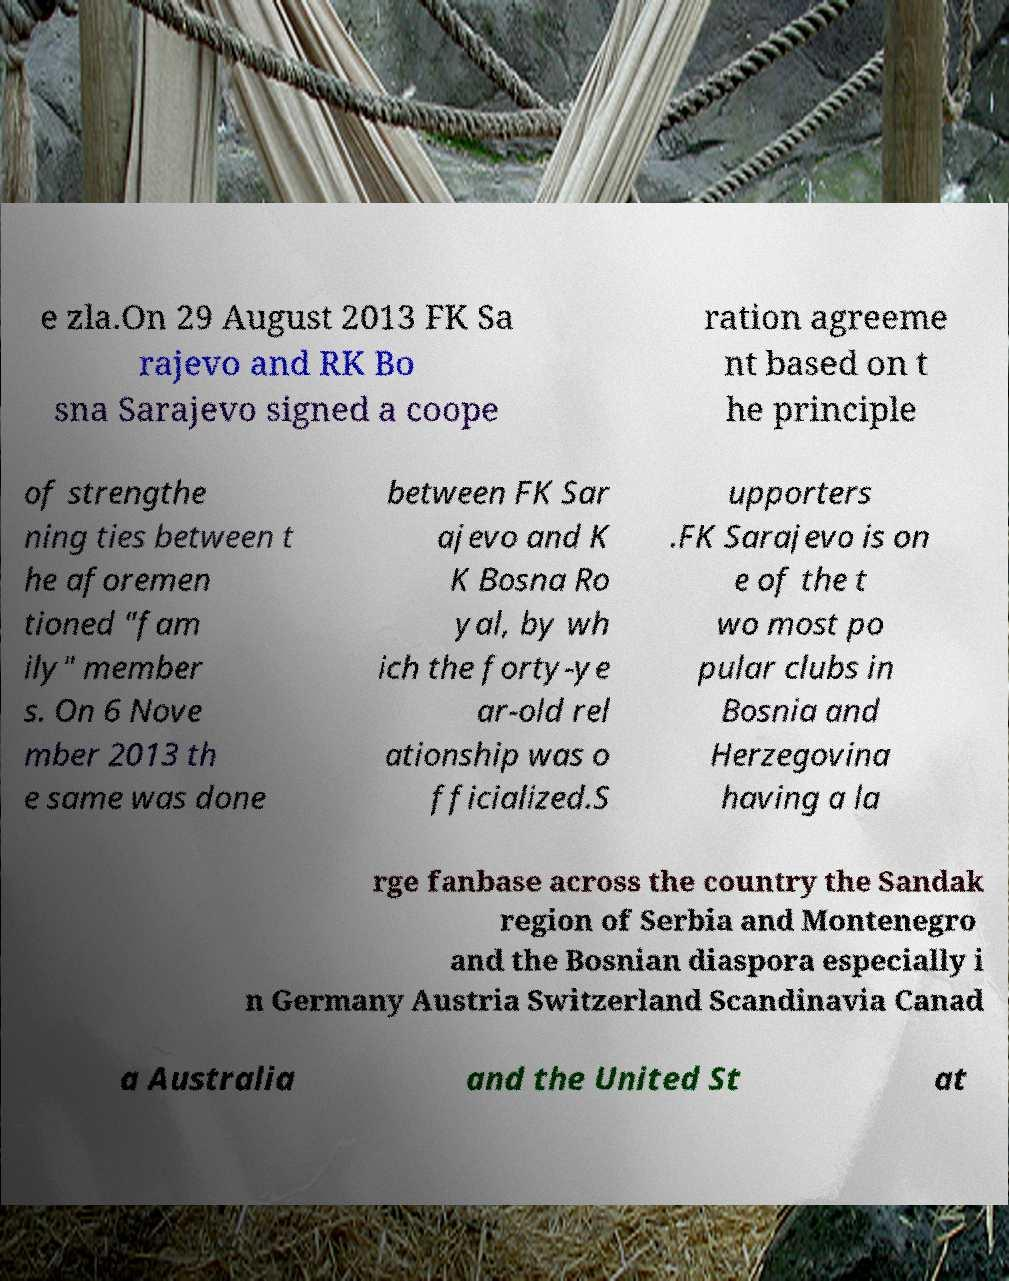Please identify and transcribe the text found in this image. e zla.On 29 August 2013 FK Sa rajevo and RK Bo sna Sarajevo signed a coope ration agreeme nt based on t he principle of strengthe ning ties between t he aforemen tioned "fam ily" member s. On 6 Nove mber 2013 th e same was done between FK Sar ajevo and K K Bosna Ro yal, by wh ich the forty-ye ar-old rel ationship was o fficialized.S upporters .FK Sarajevo is on e of the t wo most po pular clubs in Bosnia and Herzegovina having a la rge fanbase across the country the Sandak region of Serbia and Montenegro and the Bosnian diaspora especially i n Germany Austria Switzerland Scandinavia Canad a Australia and the United St at 